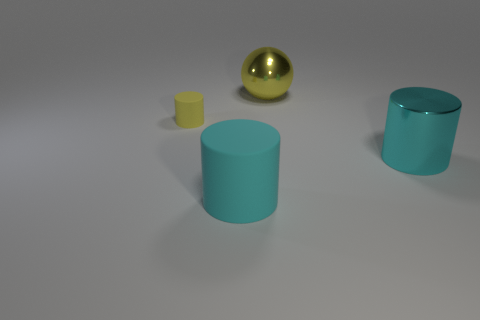If this image was to be used in an educational context, what might be the subject? The image could be used in educational materials related to geometry, to teach about shapes and volumes, or in art and design to discuss color theory and composition. 